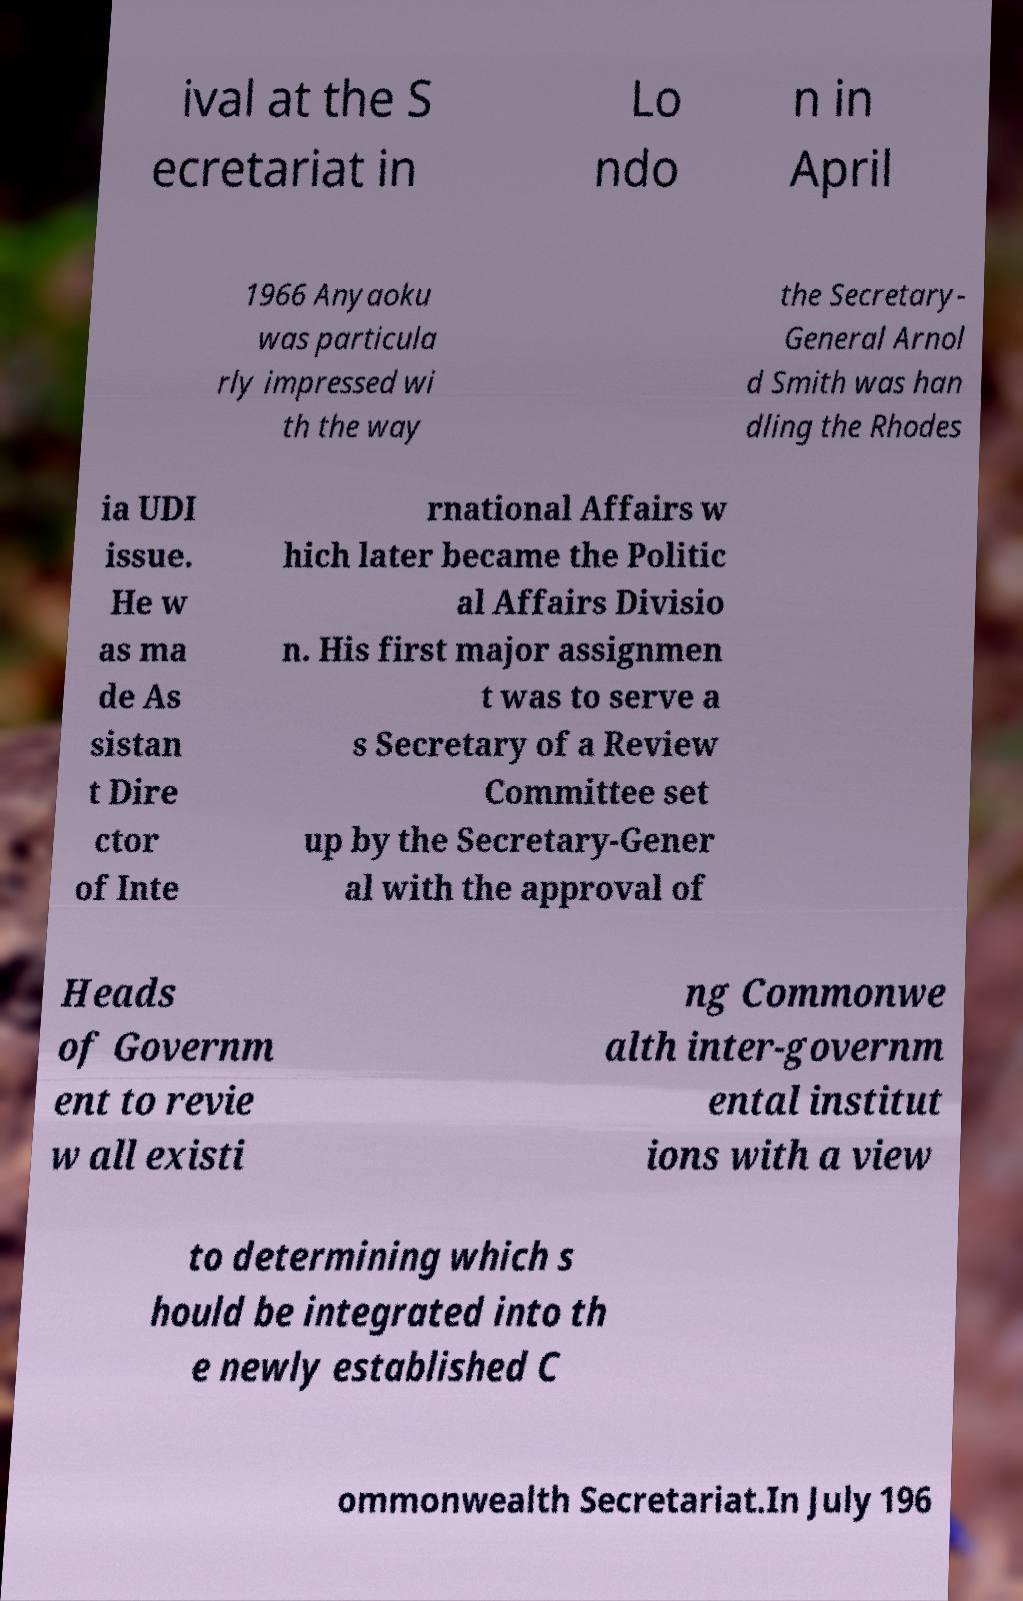Could you assist in decoding the text presented in this image and type it out clearly? ival at the S ecretariat in Lo ndo n in April 1966 Anyaoku was particula rly impressed wi th the way the Secretary- General Arnol d Smith was han dling the Rhodes ia UDI issue. He w as ma de As sistan t Dire ctor of Inte rnational Affairs w hich later became the Politic al Affairs Divisio n. His first major assignmen t was to serve a s Secretary of a Review Committee set up by the Secretary-Gener al with the approval of Heads of Governm ent to revie w all existi ng Commonwe alth inter-governm ental institut ions with a view to determining which s hould be integrated into th e newly established C ommonwealth Secretariat.In July 196 